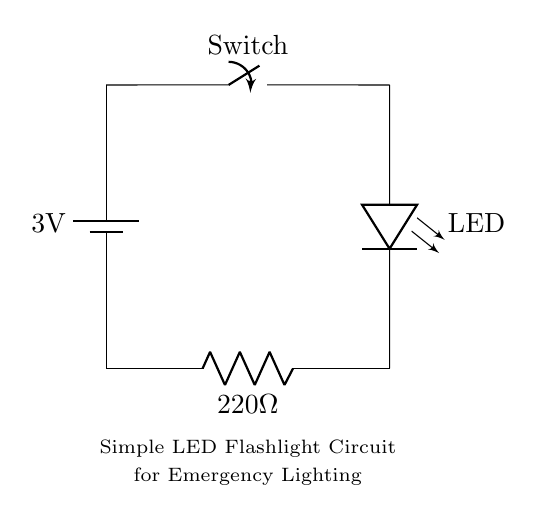What is the voltage of this circuit? The voltage is 3 volts, which is the potential difference provided by the battery in the circuit.
Answer: 3 volts What is the purpose of the switch in the circuit? The switch controls the flow of electricity, allowing the light to be turned on or off as desired. If the switch is closed, current flows to the LED; if open, current is interrupted.
Answer: Control flow What is the resistance value in this circuit? The resistance value is 220 ohms, as indicated next to the resistor component in the circuit diagram. This limits the current flowing through the LED to prevent damage.
Answer: 220 ohms How many LEDs are in this circuit? There is one LED present in the circuit, as shown in the diagram which includes a single LED symbol.
Answer: One What happens to the LED when the switch is closed? When the switch is closed, current flows through the circuit from the battery, causing the LED to light up. This is essential for the flashlight function in emergency situations.
Answer: Lights up Why is a resistor used in this circuit? The resistor limits the current flowing through the LED, protecting it from excess current that could cause it to burn out. This design consideration is crucial for prolonging the LED's lifespan.
Answer: Current limit 